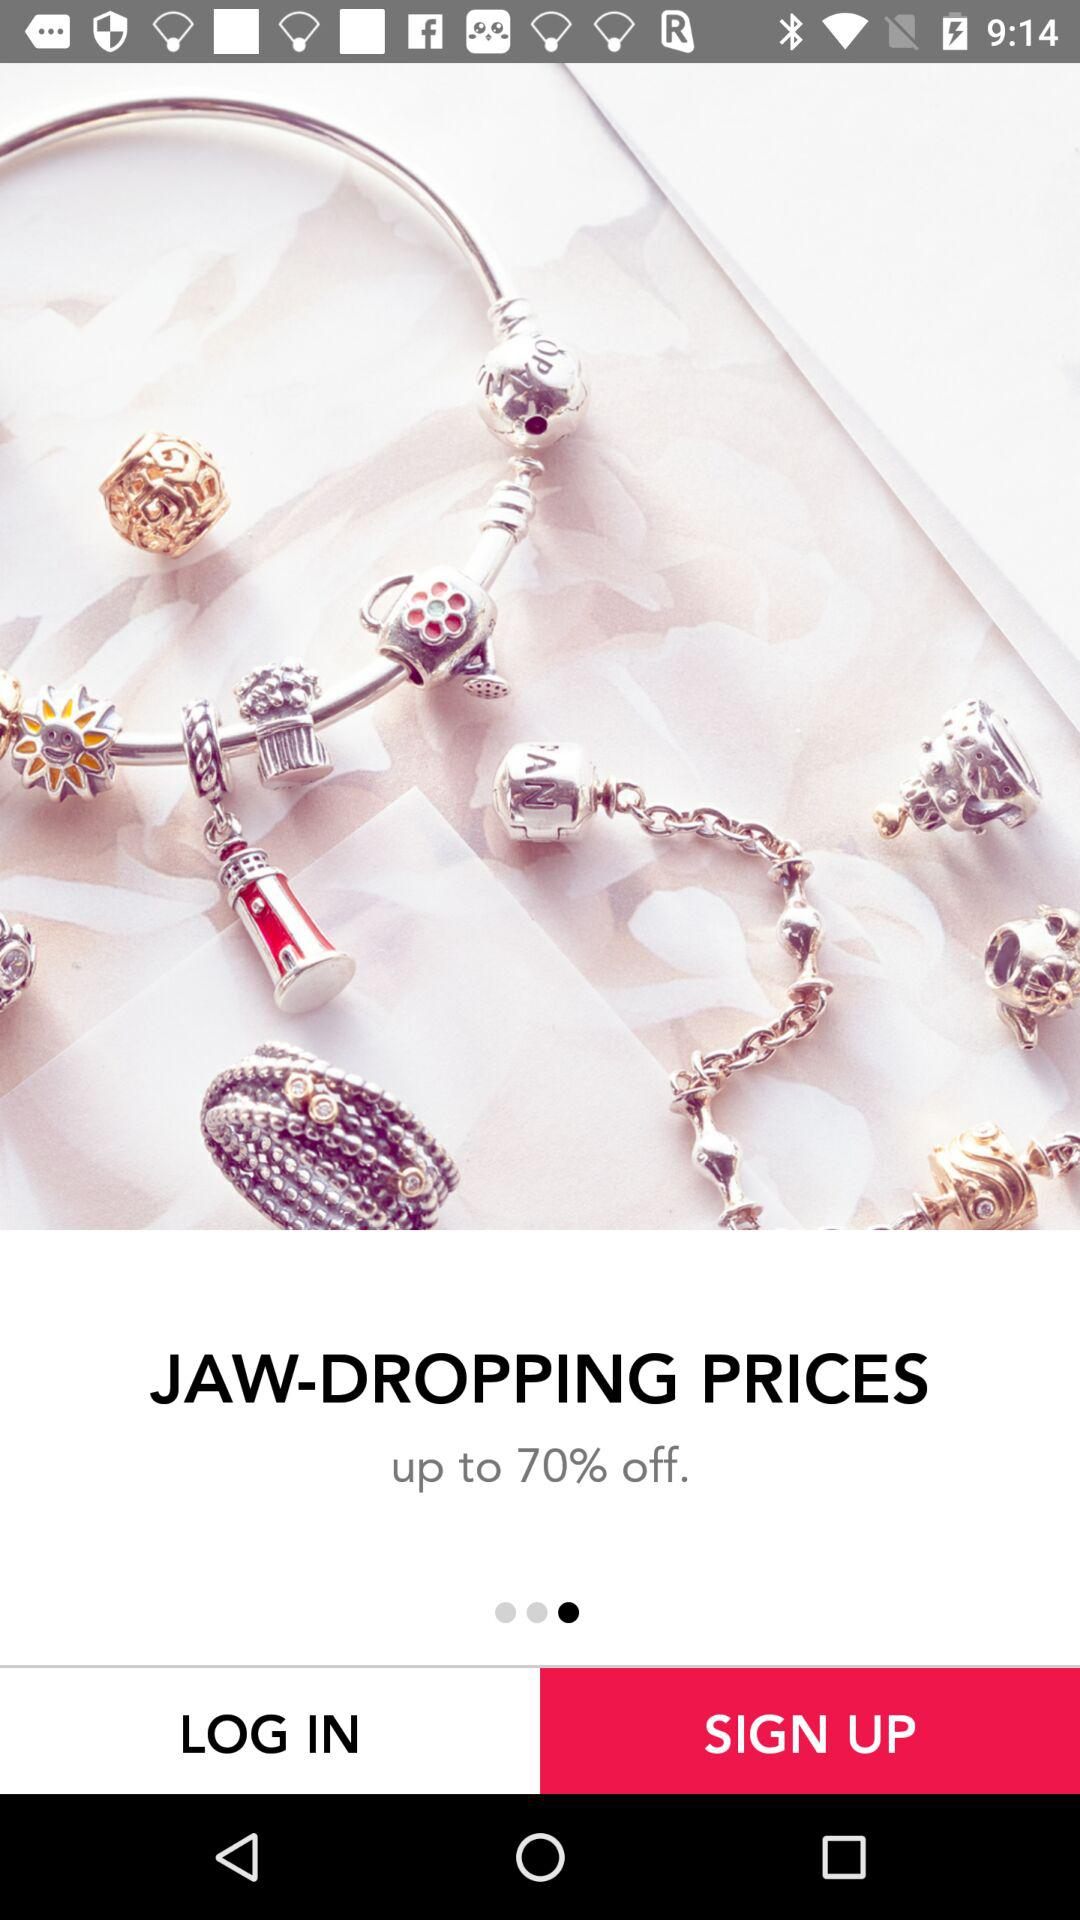What is the percent off? The percent off is up to 70. 